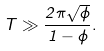<formula> <loc_0><loc_0><loc_500><loc_500>T \gg \frac { 2 \pi \sqrt { \phi } } { 1 - \phi } .</formula> 